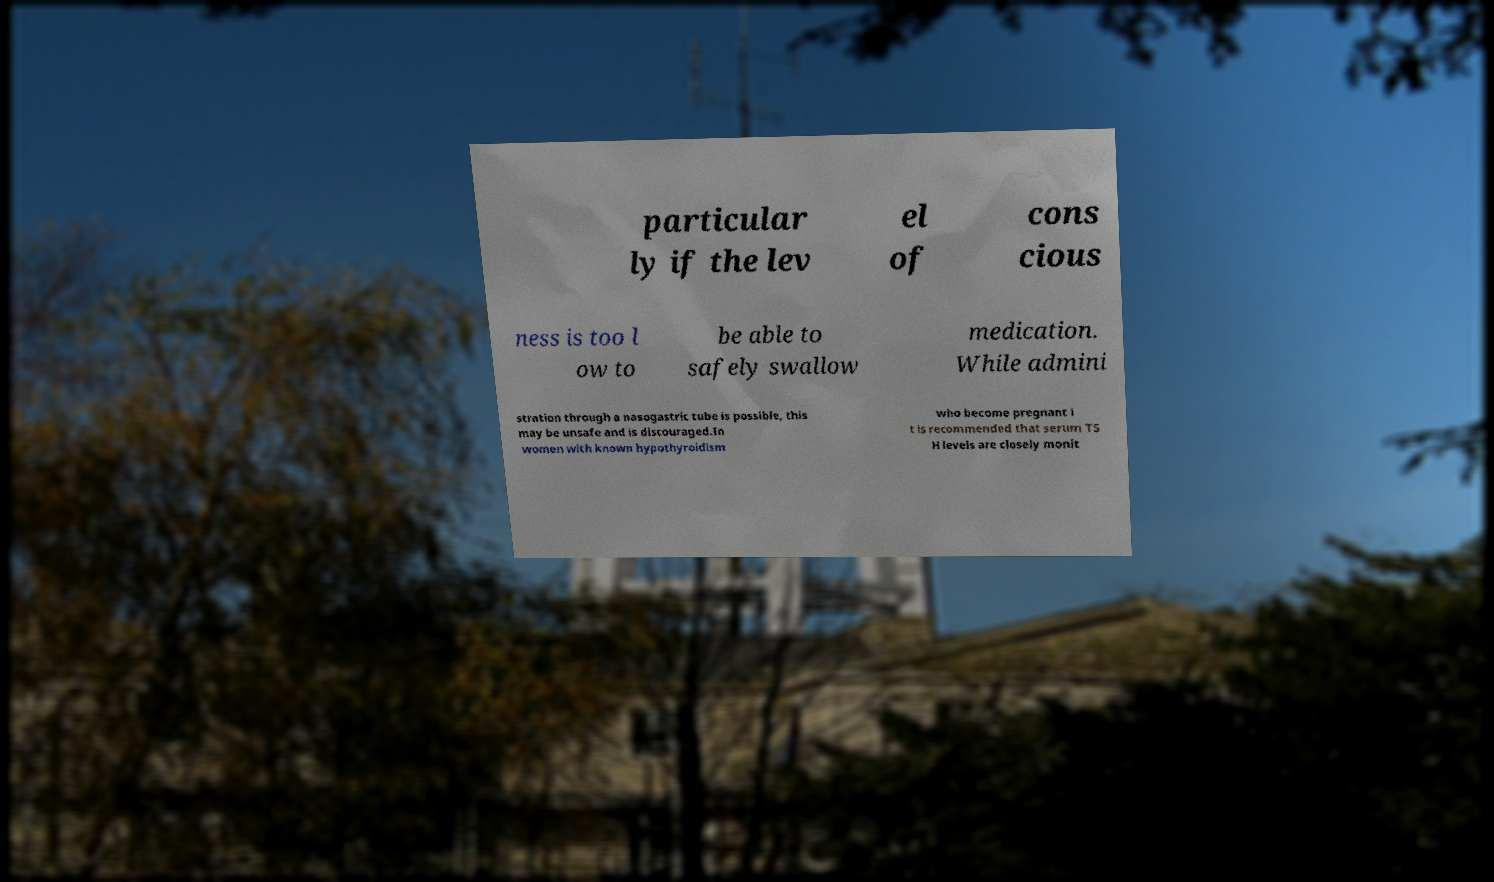For documentation purposes, I need the text within this image transcribed. Could you provide that? particular ly if the lev el of cons cious ness is too l ow to be able to safely swallow medication. While admini stration through a nasogastric tube is possible, this may be unsafe and is discouraged.In women with known hypothyroidism who become pregnant i t is recommended that serum TS H levels are closely monit 